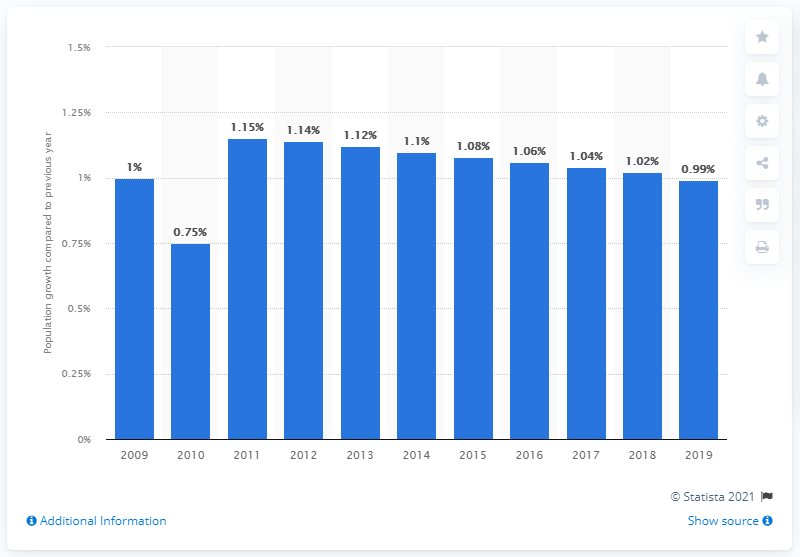Specify some key components in this picture. According to the latest estimates, Argentina's population grew by 0.99% in 2019. 